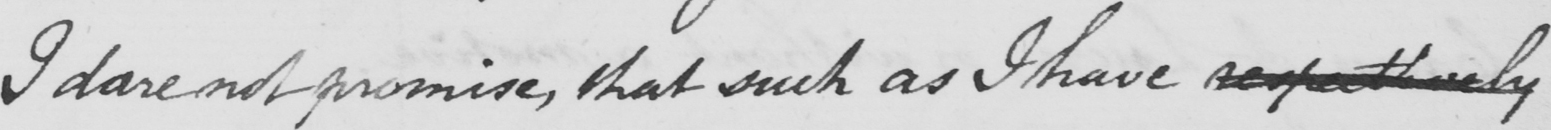Please provide the text content of this handwritten line. I dare not promise , that such as I have respectively 